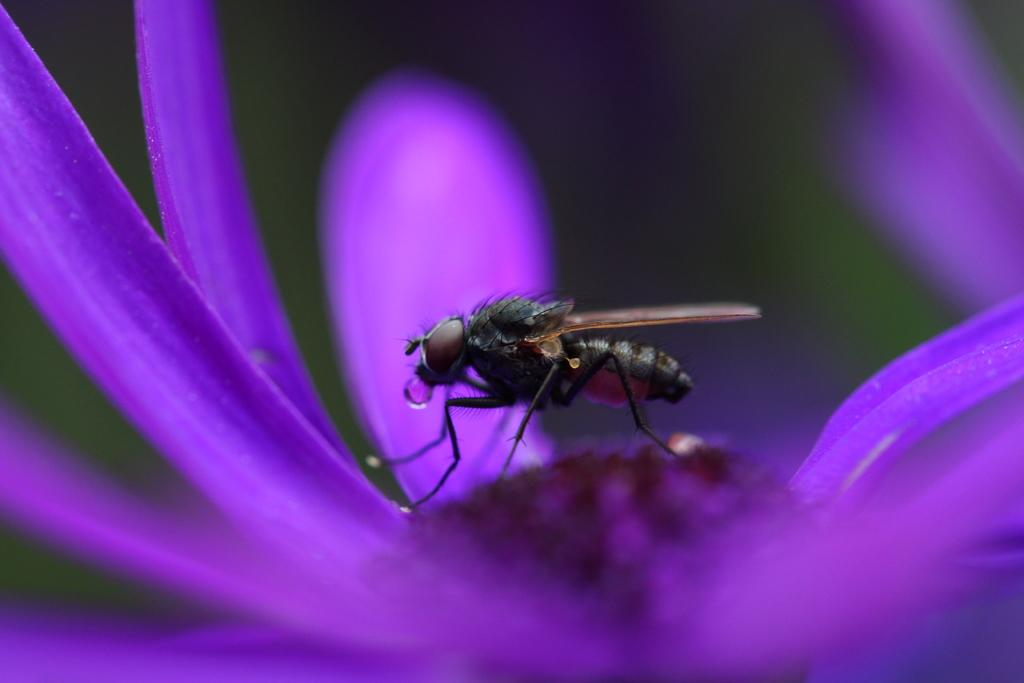What type of flower is in the image? There is a purple flower in the image. Where is the flower located in the image? The flower is in the front of the image. What other creature is present in the image? There is a fly in the image. Where is the fly located in the image? The fly is in the middle of the image. How would you describe the background of the image? The background of the image is blurry. What type of whip is being used to rub the ground in the image? There is no whip or rubbing of the ground present in the image. 